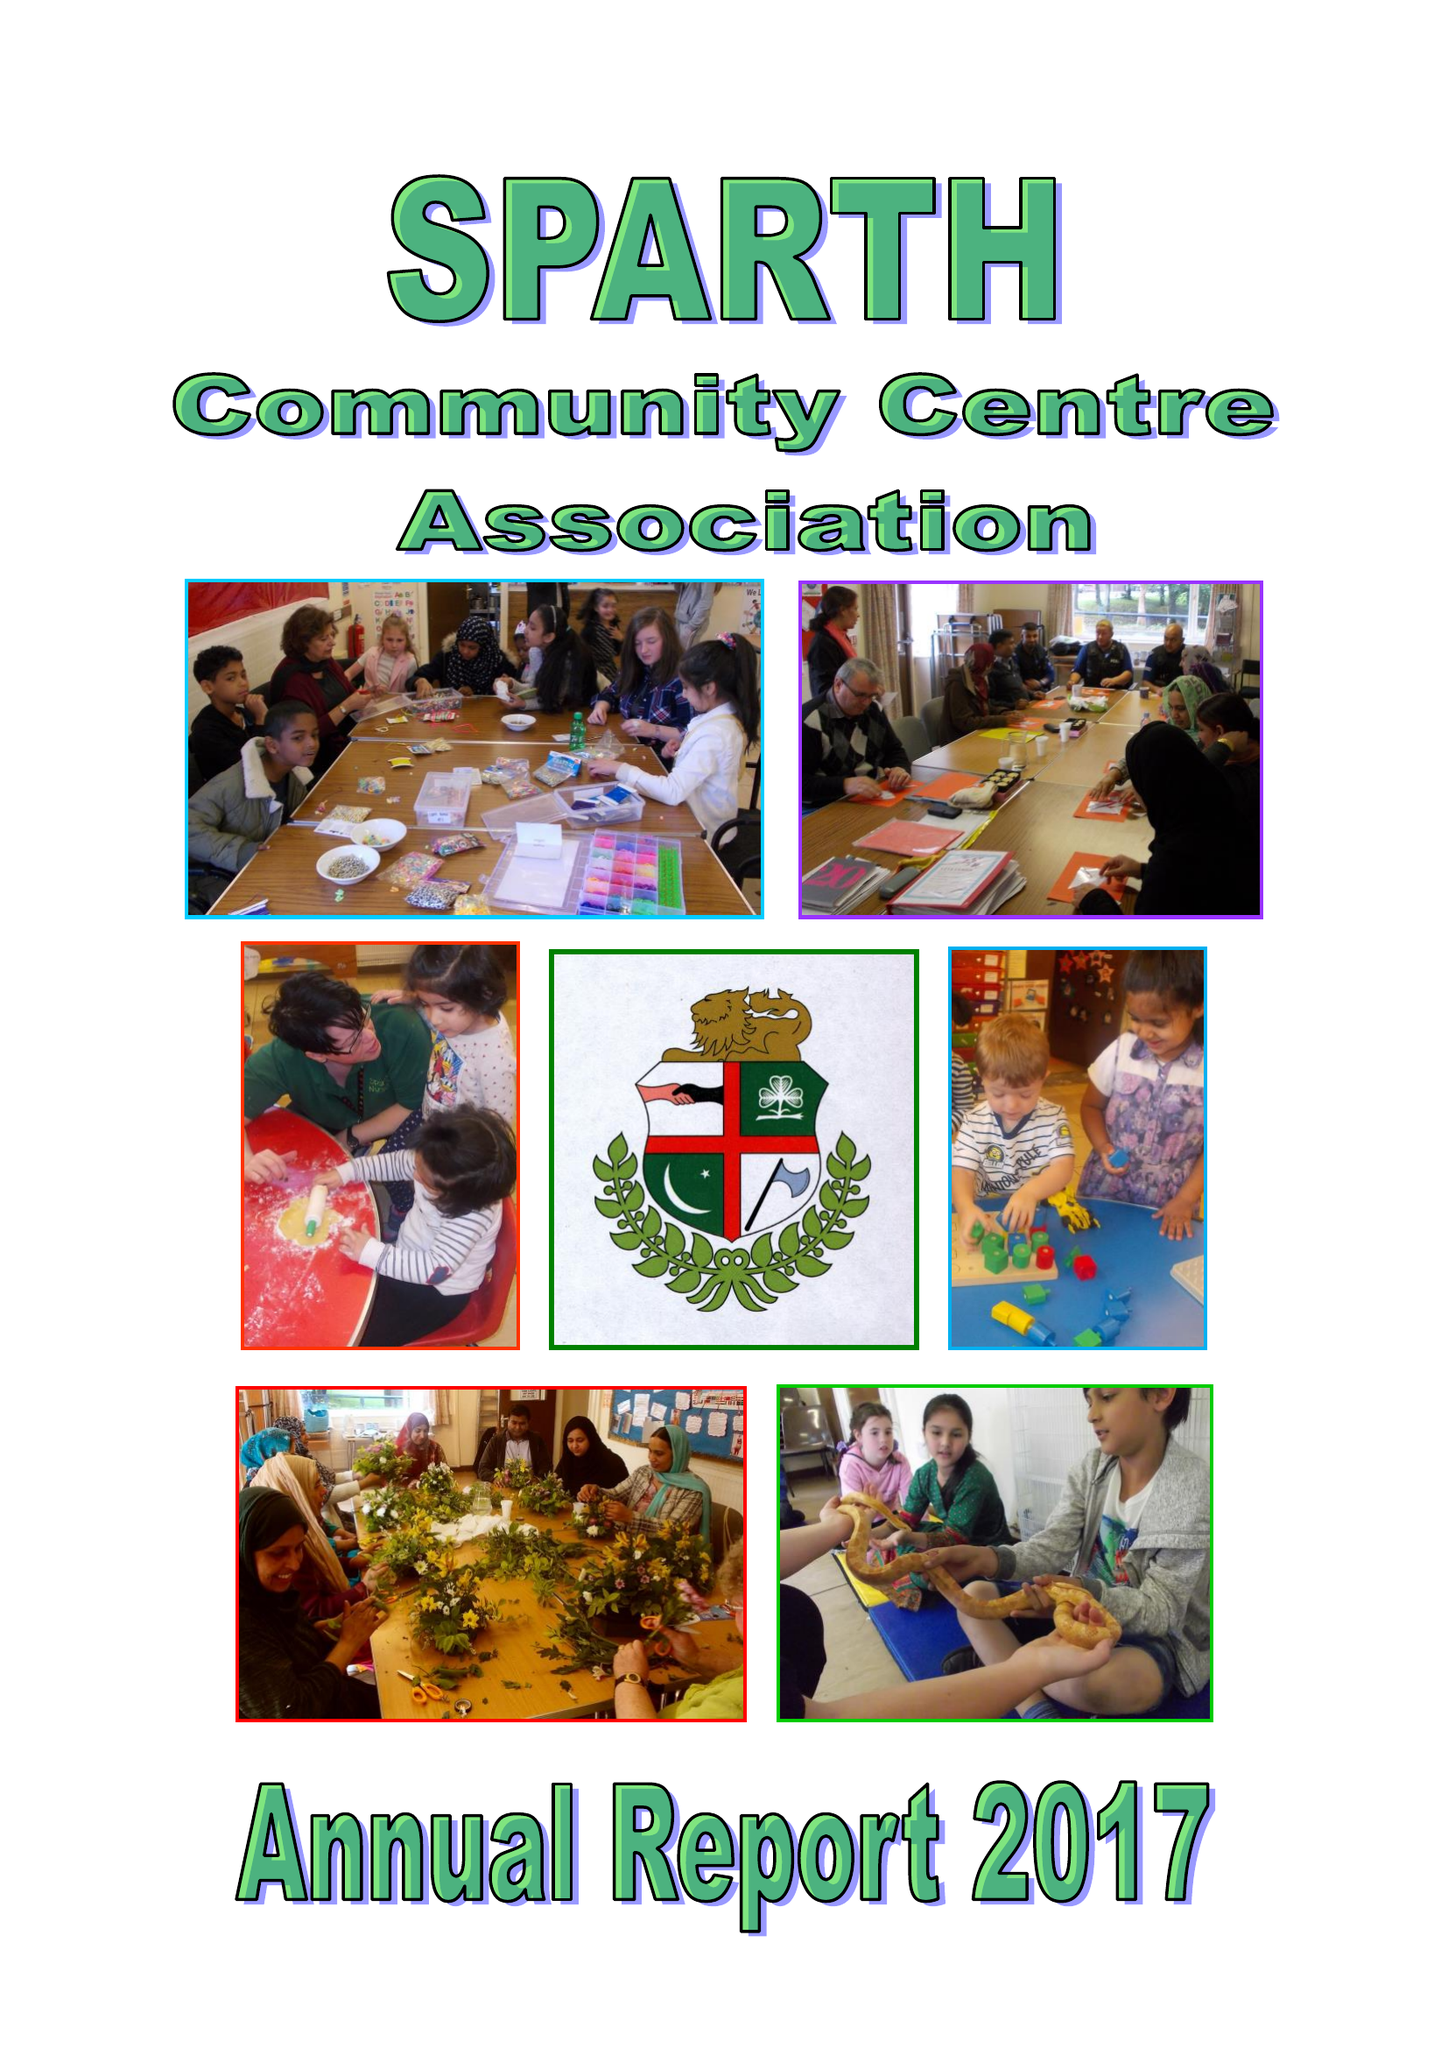What is the value for the address__street_line?
Answer the question using a single word or phrase. NORMAN ROAD 